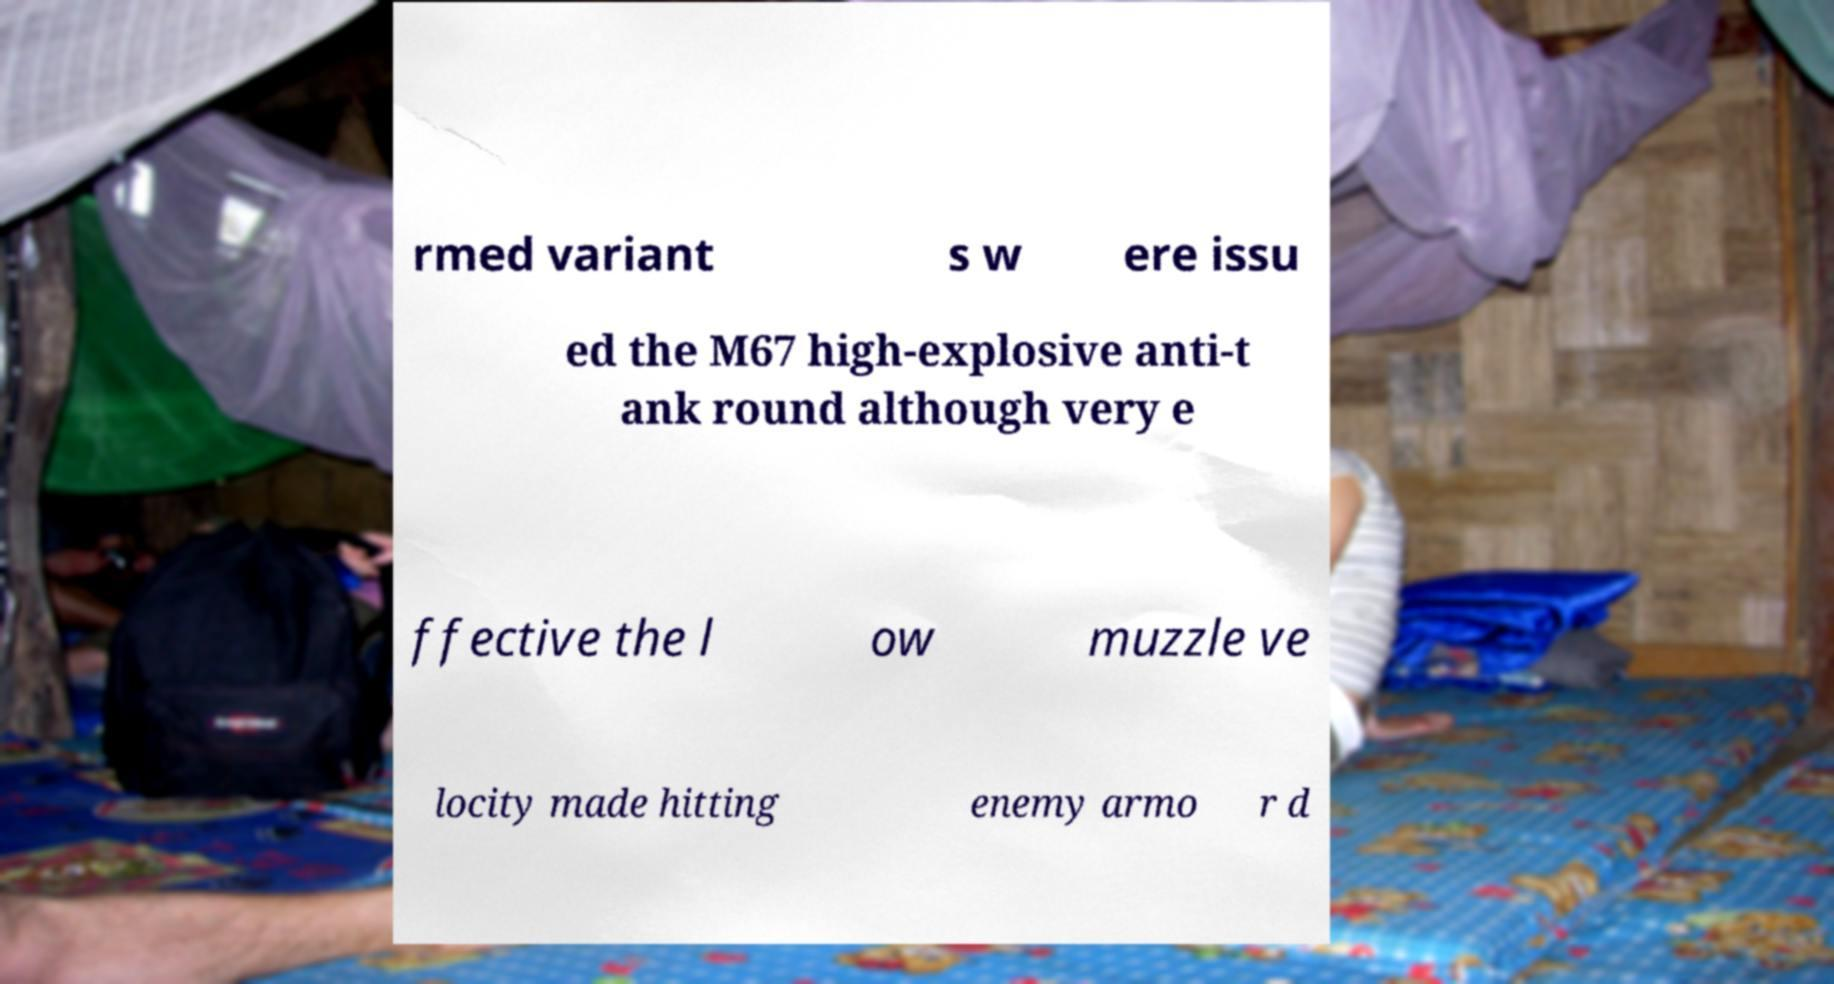I need the written content from this picture converted into text. Can you do that? rmed variant s w ere issu ed the M67 high-explosive anti-t ank round although very e ffective the l ow muzzle ve locity made hitting enemy armo r d 